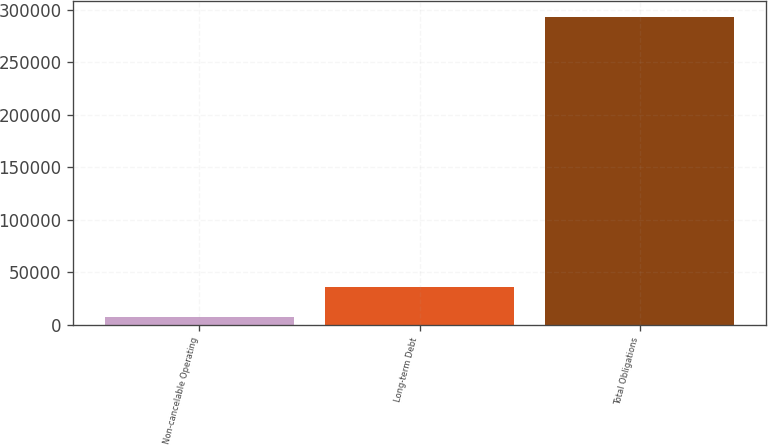<chart> <loc_0><loc_0><loc_500><loc_500><bar_chart><fcel>Non-cancelable Operating<fcel>Long-term Debt<fcel>Total Obligations<nl><fcel>7458<fcel>36032<fcel>293198<nl></chart> 